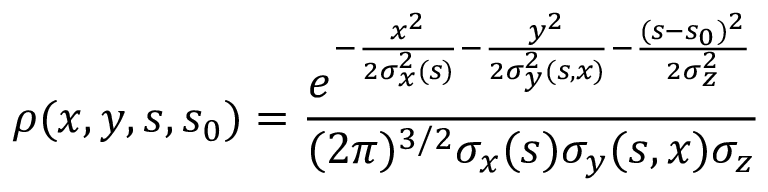Convert formula to latex. <formula><loc_0><loc_0><loc_500><loc_500>\rho ( x , y , s , s _ { 0 } ) = \frac { e ^ { - \frac { x ^ { 2 } } { 2 \sigma _ { x } ^ { 2 } ( s ) } - \frac { y ^ { 2 } } { 2 \sigma _ { y } ^ { 2 } ( s , x ) } - \frac { ( s - s _ { 0 } ) ^ { 2 } } { 2 \sigma _ { z } ^ { 2 } } } } { ( 2 \pi ) ^ { 3 / 2 } \sigma _ { x } ( s ) \sigma _ { y } ( s , x ) \sigma _ { z } }</formula> 